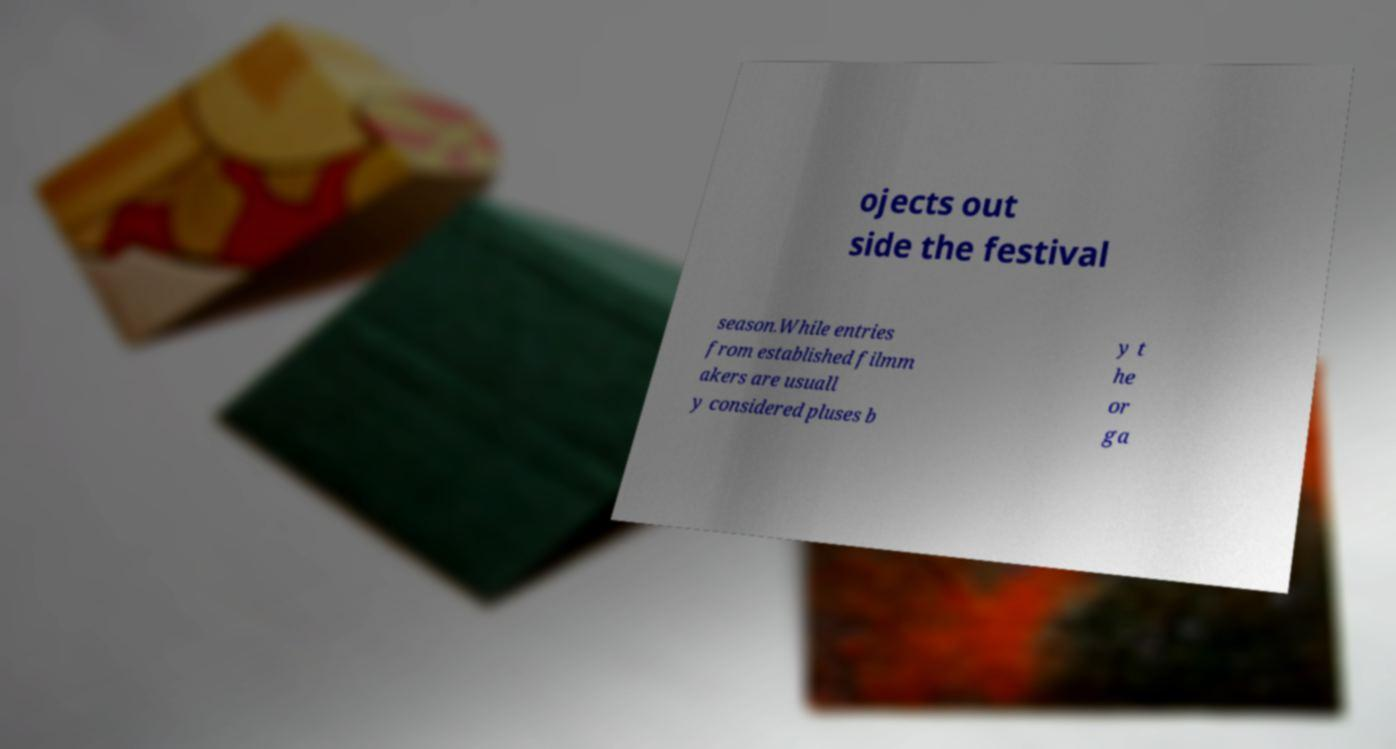Could you extract and type out the text from this image? ojects out side the festival season.While entries from established filmm akers are usuall y considered pluses b y t he or ga 